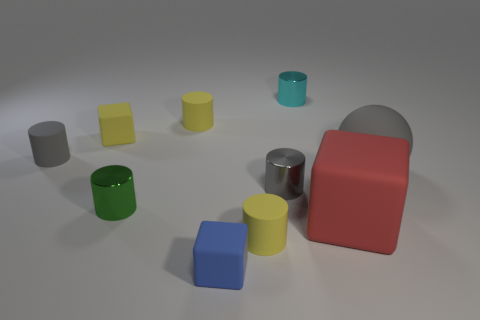Are there any blue rubber cylinders? no 